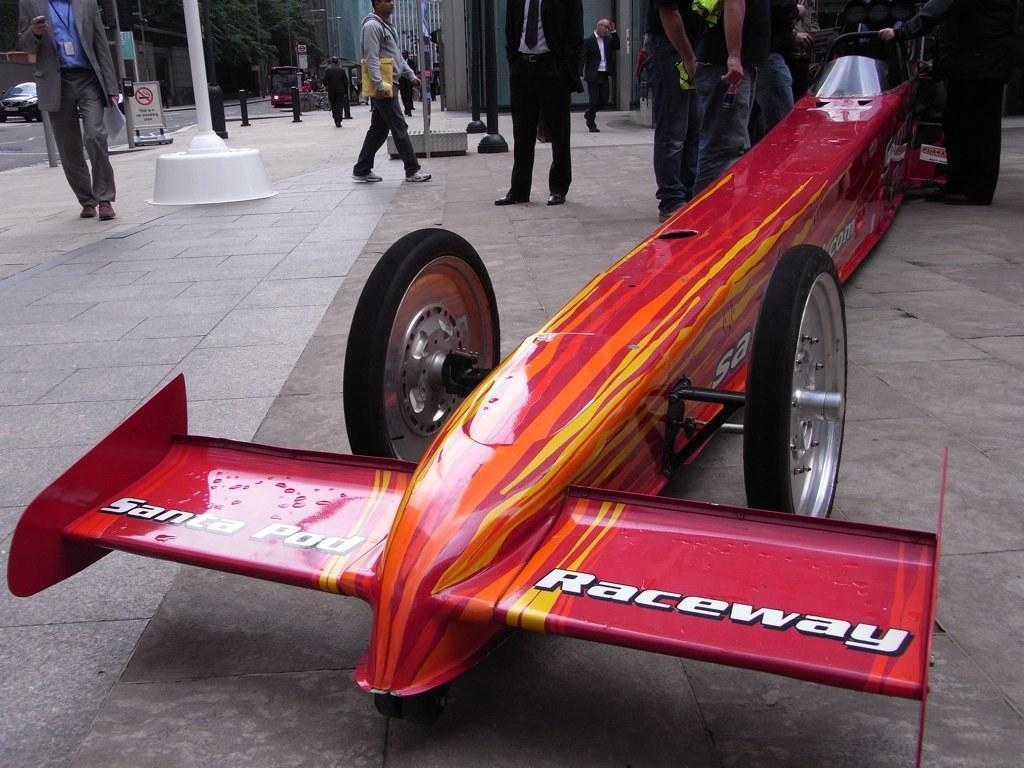What types of objects are present in the image? There are vehicles and a group of people in the image. What are the people in the image doing? Some people are standing, while others are walking. What can be seen in the background of the image? There are poles, sign boards, trees, and buildings in the background of the image. Where is the nearest market to the location depicted in the image? The image does not provide information about the location of a market, so it cannot be determined from the image. 